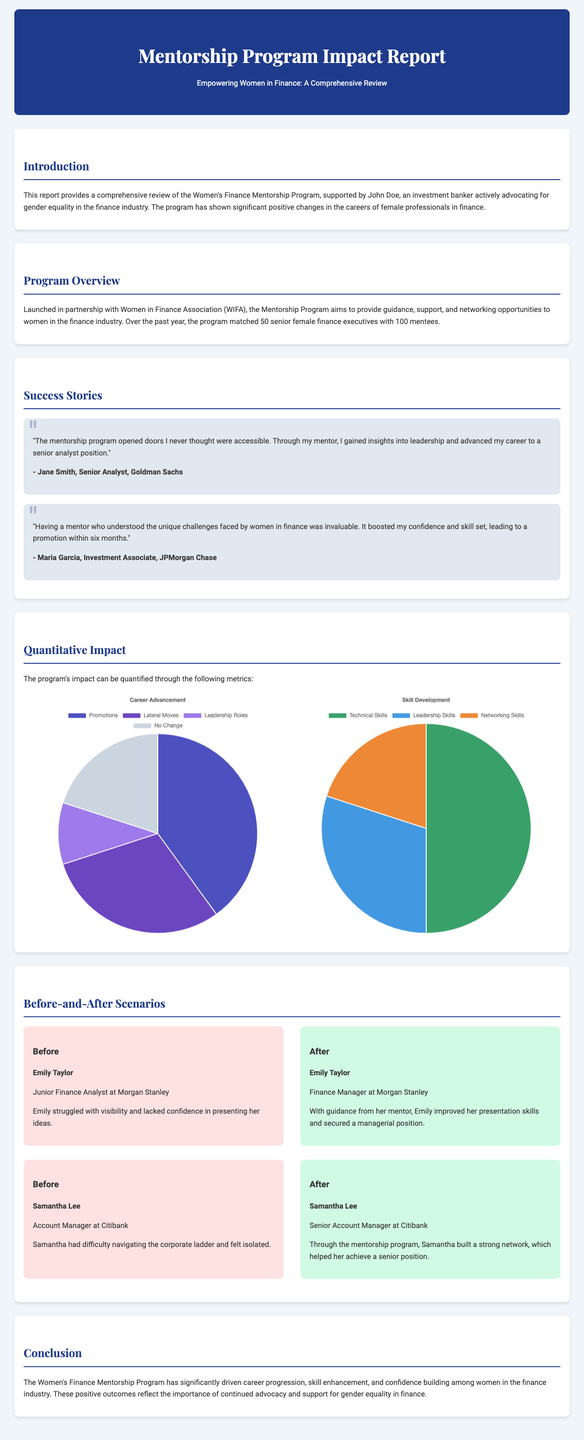What is the name of the association partnered with the Mentorship Program? The document states that the Mentorship Program was launched in partnership with the Women in Finance Association (WIFA).
Answer: Women in Finance Association (WIFA) How many senior female finance executives were matched with mentees? According to the document, the program matched 50 senior female finance executives with 100 mentees.
Answer: 50 What position did Emily Taylor hold before the mentorship program? The document describes Emily Taylor as a Junior Finance Analyst at Morgan Stanley before her mentorship experience.
Answer: Junior Finance Analyst What percentage of participants experienced no change in their career status? The pie chart indicates that 20% of participants reported no change in their career status.
Answer: 20% What skill category had the lowest percentage in development according to the charts? The skills chart shows that Networking Skills had the lowest percentage at 20%.
Answer: Networking Skills Who provided a testimonial about gaining insights into leadership? The document cites Jane Smith as the individual who provided a testimonial regarding her leadership insights gained through the program.
Answer: Jane Smith What was the primary goal of the Mentorship Program? The introduction states that the program aims to provide guidance, support, and networking opportunities to women in finance.
Answer: Guidance, support, and networking What position did Samantha Lee achieve after participating in the mentorship program? The document mentions that Samantha Lee advanced to the position of Senior Account Manager at Citibank after the program.
Answer: Senior Account Manager How many mentees were in the program? The program supported a total of 100 mentees as specified in the overview section.
Answer: 100 